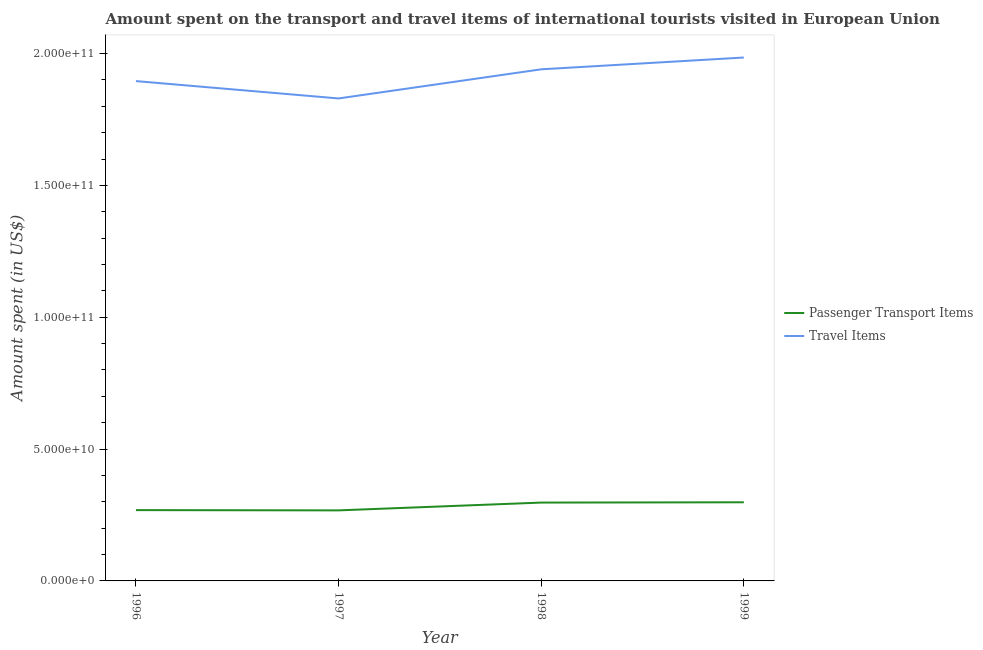How many different coloured lines are there?
Ensure brevity in your answer.  2. Is the number of lines equal to the number of legend labels?
Offer a terse response. Yes. What is the amount spent in travel items in 1996?
Provide a succinct answer. 1.90e+11. Across all years, what is the maximum amount spent in travel items?
Keep it short and to the point. 1.99e+11. Across all years, what is the minimum amount spent in travel items?
Your answer should be compact. 1.83e+11. What is the total amount spent in travel items in the graph?
Provide a short and direct response. 7.65e+11. What is the difference between the amount spent on passenger transport items in 1996 and that in 1997?
Your response must be concise. 9.81e+07. What is the difference between the amount spent on passenger transport items in 1999 and the amount spent in travel items in 1996?
Provide a short and direct response. -1.60e+11. What is the average amount spent on passenger transport items per year?
Provide a succinct answer. 2.83e+1. In the year 1999, what is the difference between the amount spent in travel items and amount spent on passenger transport items?
Your response must be concise. 1.69e+11. In how many years, is the amount spent in travel items greater than 70000000000 US$?
Your answer should be very brief. 4. What is the ratio of the amount spent in travel items in 1996 to that in 1997?
Keep it short and to the point. 1.04. What is the difference between the highest and the second highest amount spent on passenger transport items?
Provide a succinct answer. 1.11e+08. What is the difference between the highest and the lowest amount spent on passenger transport items?
Give a very brief answer. 3.07e+09. In how many years, is the amount spent in travel items greater than the average amount spent in travel items taken over all years?
Offer a very short reply. 2. Is the amount spent on passenger transport items strictly greater than the amount spent in travel items over the years?
Your answer should be compact. No. Is the amount spent in travel items strictly less than the amount spent on passenger transport items over the years?
Provide a succinct answer. No. What is the difference between two consecutive major ticks on the Y-axis?
Give a very brief answer. 5.00e+1. What is the title of the graph?
Offer a very short reply. Amount spent on the transport and travel items of international tourists visited in European Union. Does "Non-resident workers" appear as one of the legend labels in the graph?
Ensure brevity in your answer.  No. What is the label or title of the X-axis?
Your answer should be compact. Year. What is the label or title of the Y-axis?
Keep it short and to the point. Amount spent (in US$). What is the Amount spent (in US$) in Passenger Transport Items in 1996?
Your answer should be compact. 2.69e+1. What is the Amount spent (in US$) in Travel Items in 1996?
Keep it short and to the point. 1.90e+11. What is the Amount spent (in US$) of Passenger Transport Items in 1997?
Ensure brevity in your answer.  2.68e+1. What is the Amount spent (in US$) of Travel Items in 1997?
Offer a very short reply. 1.83e+11. What is the Amount spent (in US$) of Passenger Transport Items in 1998?
Offer a very short reply. 2.97e+1. What is the Amount spent (in US$) in Travel Items in 1998?
Ensure brevity in your answer.  1.94e+11. What is the Amount spent (in US$) of Passenger Transport Items in 1999?
Offer a very short reply. 2.98e+1. What is the Amount spent (in US$) of Travel Items in 1999?
Your answer should be very brief. 1.99e+11. Across all years, what is the maximum Amount spent (in US$) of Passenger Transport Items?
Provide a succinct answer. 2.98e+1. Across all years, what is the maximum Amount spent (in US$) of Travel Items?
Provide a short and direct response. 1.99e+11. Across all years, what is the minimum Amount spent (in US$) in Passenger Transport Items?
Your response must be concise. 2.68e+1. Across all years, what is the minimum Amount spent (in US$) of Travel Items?
Offer a very short reply. 1.83e+11. What is the total Amount spent (in US$) in Passenger Transport Items in the graph?
Provide a short and direct response. 1.13e+11. What is the total Amount spent (in US$) in Travel Items in the graph?
Your answer should be very brief. 7.65e+11. What is the difference between the Amount spent (in US$) of Passenger Transport Items in 1996 and that in 1997?
Provide a short and direct response. 9.81e+07. What is the difference between the Amount spent (in US$) of Travel Items in 1996 and that in 1997?
Make the answer very short. 6.58e+09. What is the difference between the Amount spent (in US$) of Passenger Transport Items in 1996 and that in 1998?
Your response must be concise. -2.86e+09. What is the difference between the Amount spent (in US$) in Travel Items in 1996 and that in 1998?
Your answer should be very brief. -4.47e+09. What is the difference between the Amount spent (in US$) of Passenger Transport Items in 1996 and that in 1999?
Offer a terse response. -2.97e+09. What is the difference between the Amount spent (in US$) in Travel Items in 1996 and that in 1999?
Offer a very short reply. -8.94e+09. What is the difference between the Amount spent (in US$) in Passenger Transport Items in 1997 and that in 1998?
Your answer should be very brief. -2.96e+09. What is the difference between the Amount spent (in US$) in Travel Items in 1997 and that in 1998?
Offer a terse response. -1.10e+1. What is the difference between the Amount spent (in US$) of Passenger Transport Items in 1997 and that in 1999?
Ensure brevity in your answer.  -3.07e+09. What is the difference between the Amount spent (in US$) of Travel Items in 1997 and that in 1999?
Your response must be concise. -1.55e+1. What is the difference between the Amount spent (in US$) of Passenger Transport Items in 1998 and that in 1999?
Offer a very short reply. -1.11e+08. What is the difference between the Amount spent (in US$) of Travel Items in 1998 and that in 1999?
Make the answer very short. -4.47e+09. What is the difference between the Amount spent (in US$) of Passenger Transport Items in 1996 and the Amount spent (in US$) of Travel Items in 1997?
Make the answer very short. -1.56e+11. What is the difference between the Amount spent (in US$) in Passenger Transport Items in 1996 and the Amount spent (in US$) in Travel Items in 1998?
Offer a very short reply. -1.67e+11. What is the difference between the Amount spent (in US$) in Passenger Transport Items in 1996 and the Amount spent (in US$) in Travel Items in 1999?
Make the answer very short. -1.72e+11. What is the difference between the Amount spent (in US$) of Passenger Transport Items in 1997 and the Amount spent (in US$) of Travel Items in 1998?
Make the answer very short. -1.67e+11. What is the difference between the Amount spent (in US$) in Passenger Transport Items in 1997 and the Amount spent (in US$) in Travel Items in 1999?
Offer a terse response. -1.72e+11. What is the difference between the Amount spent (in US$) in Passenger Transport Items in 1998 and the Amount spent (in US$) in Travel Items in 1999?
Give a very brief answer. -1.69e+11. What is the average Amount spent (in US$) of Passenger Transport Items per year?
Provide a short and direct response. 2.83e+1. What is the average Amount spent (in US$) in Travel Items per year?
Your answer should be compact. 1.91e+11. In the year 1996, what is the difference between the Amount spent (in US$) of Passenger Transport Items and Amount spent (in US$) of Travel Items?
Keep it short and to the point. -1.63e+11. In the year 1997, what is the difference between the Amount spent (in US$) of Passenger Transport Items and Amount spent (in US$) of Travel Items?
Your response must be concise. -1.56e+11. In the year 1998, what is the difference between the Amount spent (in US$) of Passenger Transport Items and Amount spent (in US$) of Travel Items?
Give a very brief answer. -1.64e+11. In the year 1999, what is the difference between the Amount spent (in US$) in Passenger Transport Items and Amount spent (in US$) in Travel Items?
Keep it short and to the point. -1.69e+11. What is the ratio of the Amount spent (in US$) in Travel Items in 1996 to that in 1997?
Make the answer very short. 1.04. What is the ratio of the Amount spent (in US$) in Passenger Transport Items in 1996 to that in 1998?
Your response must be concise. 0.9. What is the ratio of the Amount spent (in US$) in Travel Items in 1996 to that in 1998?
Your answer should be compact. 0.98. What is the ratio of the Amount spent (in US$) in Passenger Transport Items in 1996 to that in 1999?
Your answer should be compact. 0.9. What is the ratio of the Amount spent (in US$) of Travel Items in 1996 to that in 1999?
Offer a terse response. 0.95. What is the ratio of the Amount spent (in US$) in Passenger Transport Items in 1997 to that in 1998?
Provide a short and direct response. 0.9. What is the ratio of the Amount spent (in US$) in Travel Items in 1997 to that in 1998?
Your answer should be very brief. 0.94. What is the ratio of the Amount spent (in US$) in Passenger Transport Items in 1997 to that in 1999?
Offer a very short reply. 0.9. What is the ratio of the Amount spent (in US$) in Travel Items in 1997 to that in 1999?
Your answer should be very brief. 0.92. What is the ratio of the Amount spent (in US$) in Travel Items in 1998 to that in 1999?
Provide a short and direct response. 0.98. What is the difference between the highest and the second highest Amount spent (in US$) of Passenger Transport Items?
Keep it short and to the point. 1.11e+08. What is the difference between the highest and the second highest Amount spent (in US$) in Travel Items?
Offer a very short reply. 4.47e+09. What is the difference between the highest and the lowest Amount spent (in US$) of Passenger Transport Items?
Offer a very short reply. 3.07e+09. What is the difference between the highest and the lowest Amount spent (in US$) in Travel Items?
Your response must be concise. 1.55e+1. 